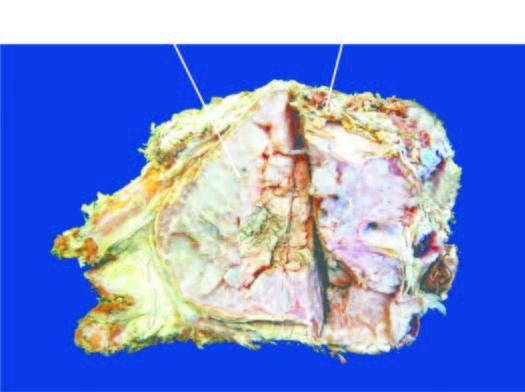how does sectioned surface show lobulated mass?
Answer the question using a single word or phrase. With bluish cartilaginous hue infiltrating the soft tissues 